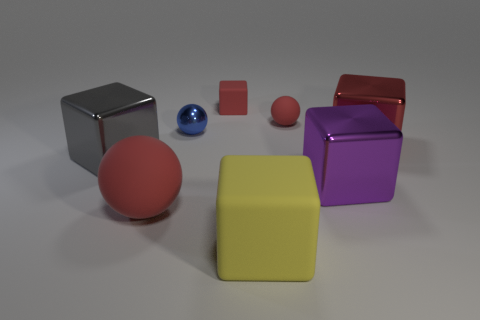What number of tiny matte objects are the same color as the small rubber ball?
Ensure brevity in your answer.  1. What is the shape of the shiny thing on the left side of the ball that is in front of the big red metallic object?
Give a very brief answer. Cube. Are there an equal number of small red metallic cylinders and metal cubes?
Offer a very short reply. No. What number of big purple cubes have the same material as the blue object?
Ensure brevity in your answer.  1. There is a ball in front of the large gray cube; what material is it?
Offer a terse response. Rubber. There is a small red matte thing that is in front of the rubber thing that is behind the red ball right of the tiny blue thing; what is its shape?
Your response must be concise. Sphere. There is a rubber ball that is in front of the big red metallic thing; does it have the same color as the rubber cube behind the big matte cube?
Ensure brevity in your answer.  Yes. Are there fewer big red cubes on the left side of the large yellow thing than large rubber things that are on the right side of the purple metallic object?
Provide a short and direct response. No. Is there anything else that is the same shape as the gray shiny thing?
Your answer should be compact. Yes. The big object that is the same shape as the small blue metallic thing is what color?
Your answer should be very brief. Red. 